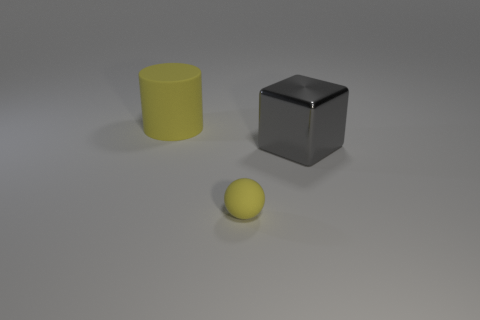Is the big matte object the same shape as the small yellow matte object? no 